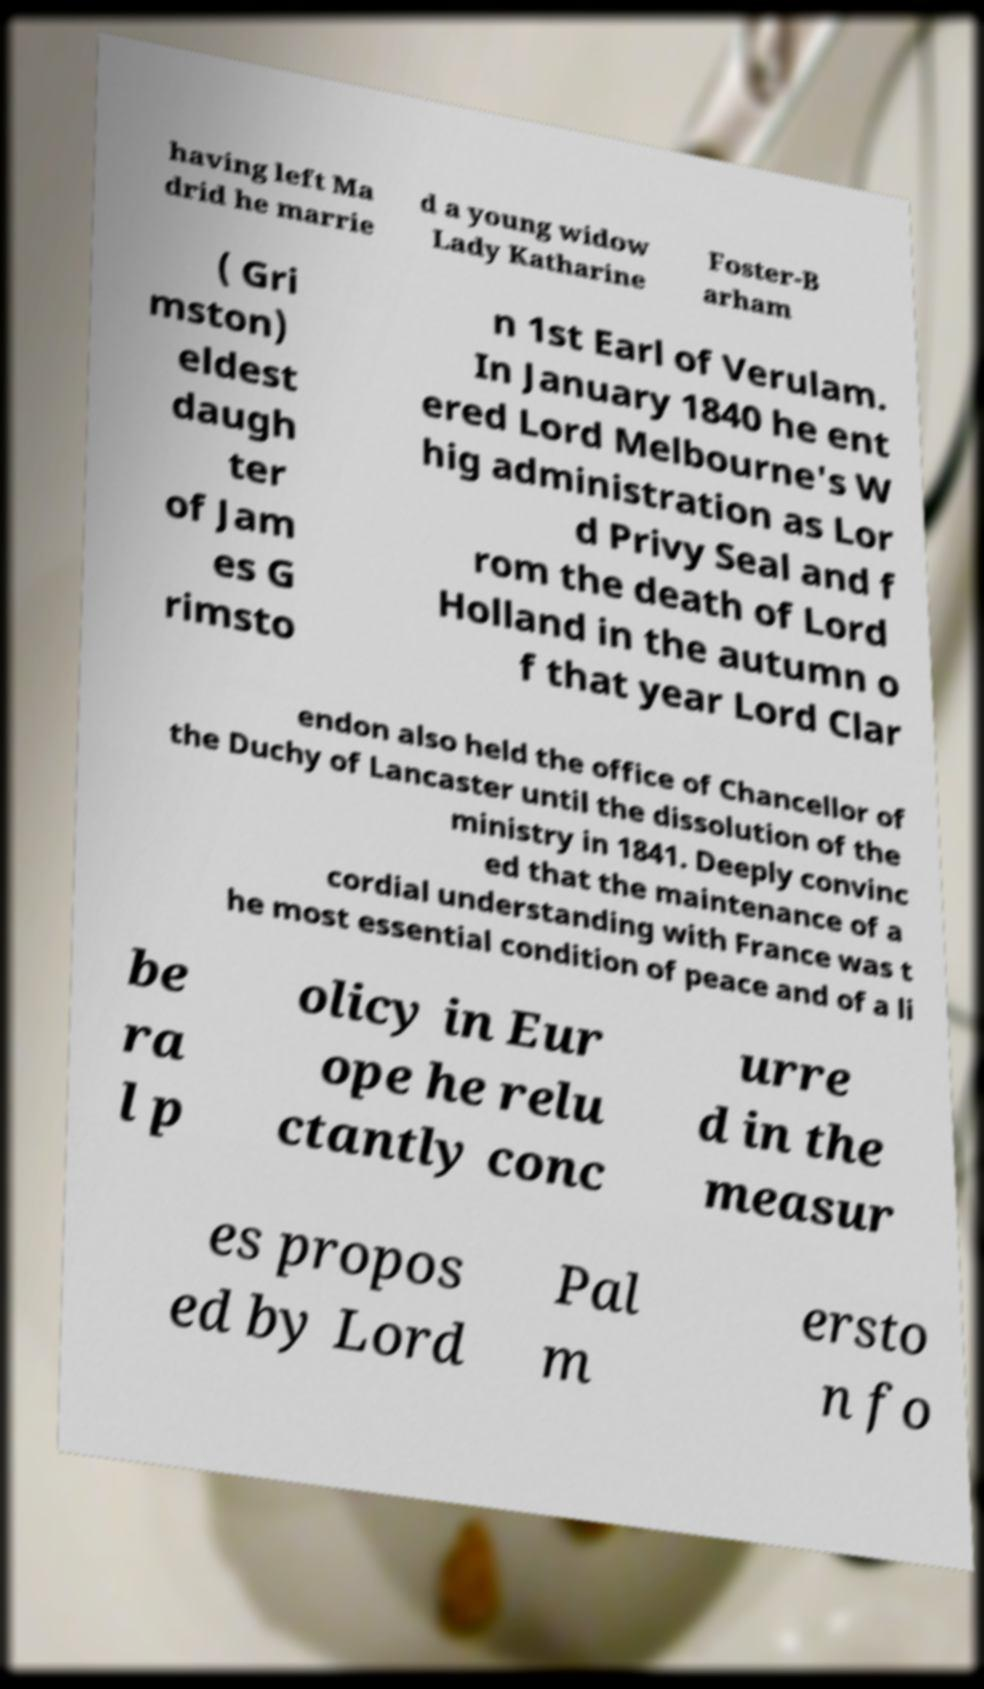Can you read and provide the text displayed in the image?This photo seems to have some interesting text. Can you extract and type it out for me? having left Ma drid he marrie d a young widow Lady Katharine Foster-B arham ( Gri mston) eldest daugh ter of Jam es G rimsto n 1st Earl of Verulam. In January 1840 he ent ered Lord Melbourne's W hig administration as Lor d Privy Seal and f rom the death of Lord Holland in the autumn o f that year Lord Clar endon also held the office of Chancellor of the Duchy of Lancaster until the dissolution of the ministry in 1841. Deeply convinc ed that the maintenance of a cordial understanding with France was t he most essential condition of peace and of a li be ra l p olicy in Eur ope he relu ctantly conc urre d in the measur es propos ed by Lord Pal m ersto n fo 